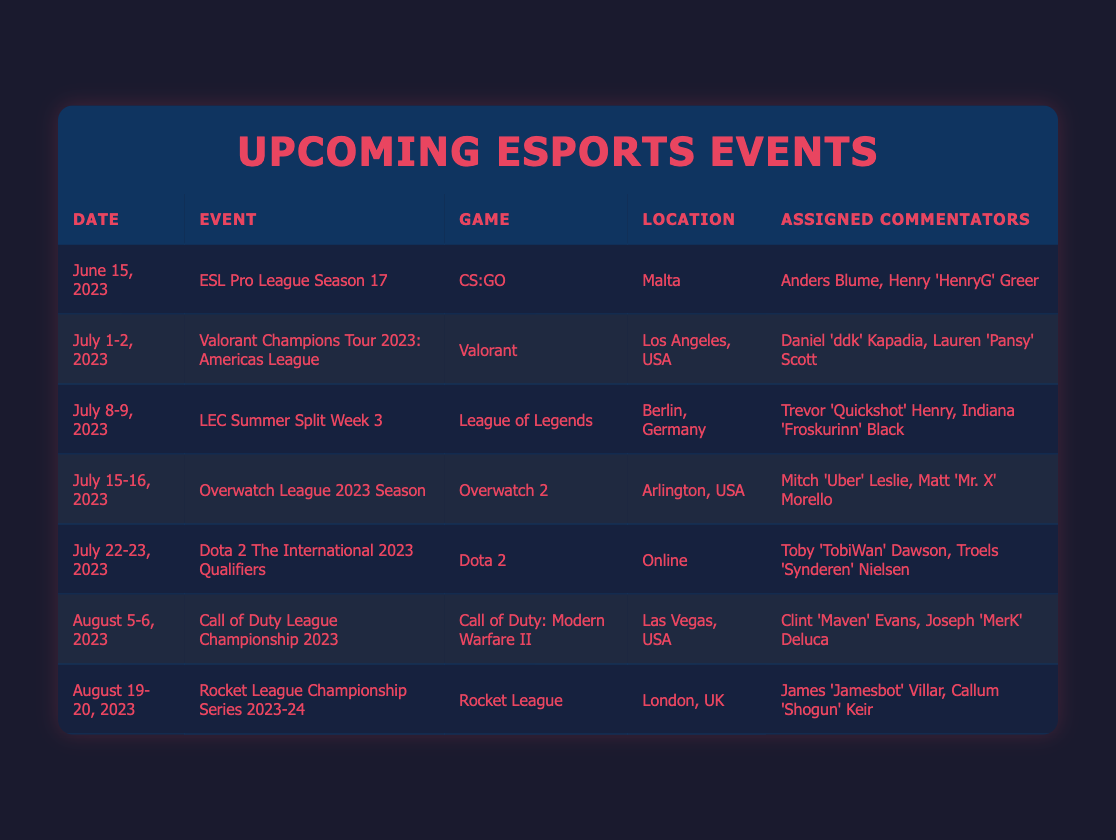What event is taking place in Malta on June 15, 2023? The table shows that on June 15, 2023, the event taking place in Malta is the ESL Pro League Season 17.
Answer: ESL Pro League Season 17 Who are the commentators for the Valorant Champions Tour 2023: Americas League? According to the table, the assigned commentators for the Valorant Champions Tour 2023: Americas League are Daniel 'ddk' Kapadia and Lauren 'Pansy' Scott.
Answer: Daniel 'ddk' Kapadia, Lauren 'Pansy' Scott How many esports events are scheduled for July 2023? The table lists three events scheduled in July 2023: Valorant Champions Tour, LEC Summer Split Week 3, and Overwatch League, making a total of three events.
Answer: 3 Is there an esports event in August 2023 that involves Call of Duty? The table confirms that there is an event in August 2023, specifically the Call of Duty League Championship 2023, which involves Call of Duty.
Answer: Yes Which location hosts the Dota 2 The International 2023 Qualifiers? The table indicates that the Dota 2 The International 2023 Qualifiers will be held online, as specified under the Location column.
Answer: Online How many commentators are assigned to the Rocket League Championship Series 2023-24? The table shows that the Rocket League Championship Series 2023-24 has two assigned commentators: James 'Jamesbot' Villar and Callum 'Shogun' Keir.
Answer: 2 Which game has the earliest event, and when is it? By checking the table, the earliest event is ESL Pro League Season 17 for the game CS:GO, occurring on June 15, 2023.
Answer: CS:GO on June 15, 2023 What is the total number of events listed between June and August 2023? The table lists a total of seven events between June (1), July (3), and August (3), adding up to seven events total.
Answer: 7 Which event in July has commentators including Mitch 'Uber' Leslie? The table specifies that the event in July with commentators Mitch 'Uber' Leslie and Matt 'Mr. X' Morello is the Overwatch League 2023 Season, scheduled for July 15-16, 2023.
Answer: Overwatch League 2023 Season 